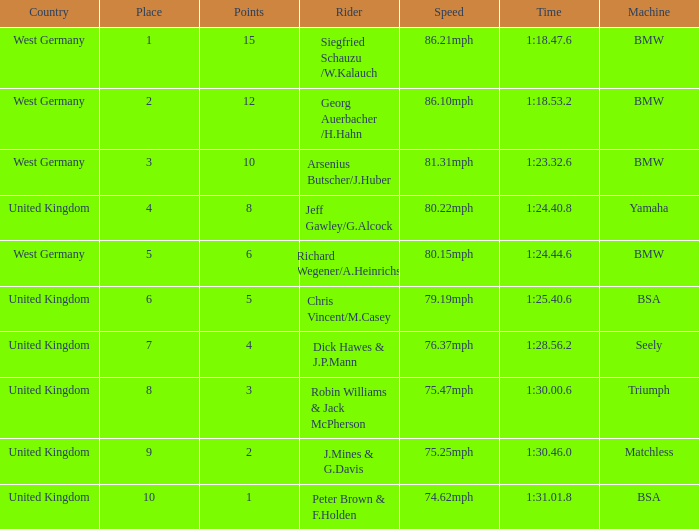Which place has points larger than 1, a bmw machine, and a time of 1:18.47.6? 1.0. 